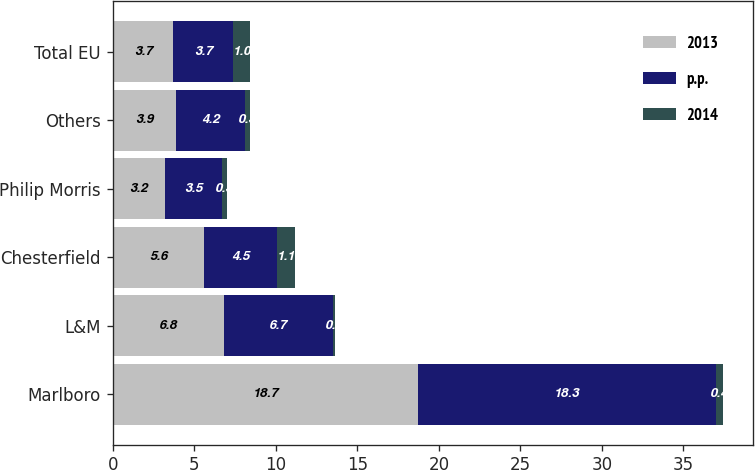Convert chart to OTSL. <chart><loc_0><loc_0><loc_500><loc_500><stacked_bar_chart><ecel><fcel>Marlboro<fcel>L&M<fcel>Chesterfield<fcel>Philip Morris<fcel>Others<fcel>Total EU<nl><fcel>2013<fcel>18.7<fcel>6.8<fcel>5.6<fcel>3.2<fcel>3.9<fcel>3.7<nl><fcel>p.p.<fcel>18.3<fcel>6.7<fcel>4.5<fcel>3.5<fcel>4.2<fcel>3.7<nl><fcel>2014<fcel>0.4<fcel>0.1<fcel>1.1<fcel>0.3<fcel>0.3<fcel>1<nl></chart> 